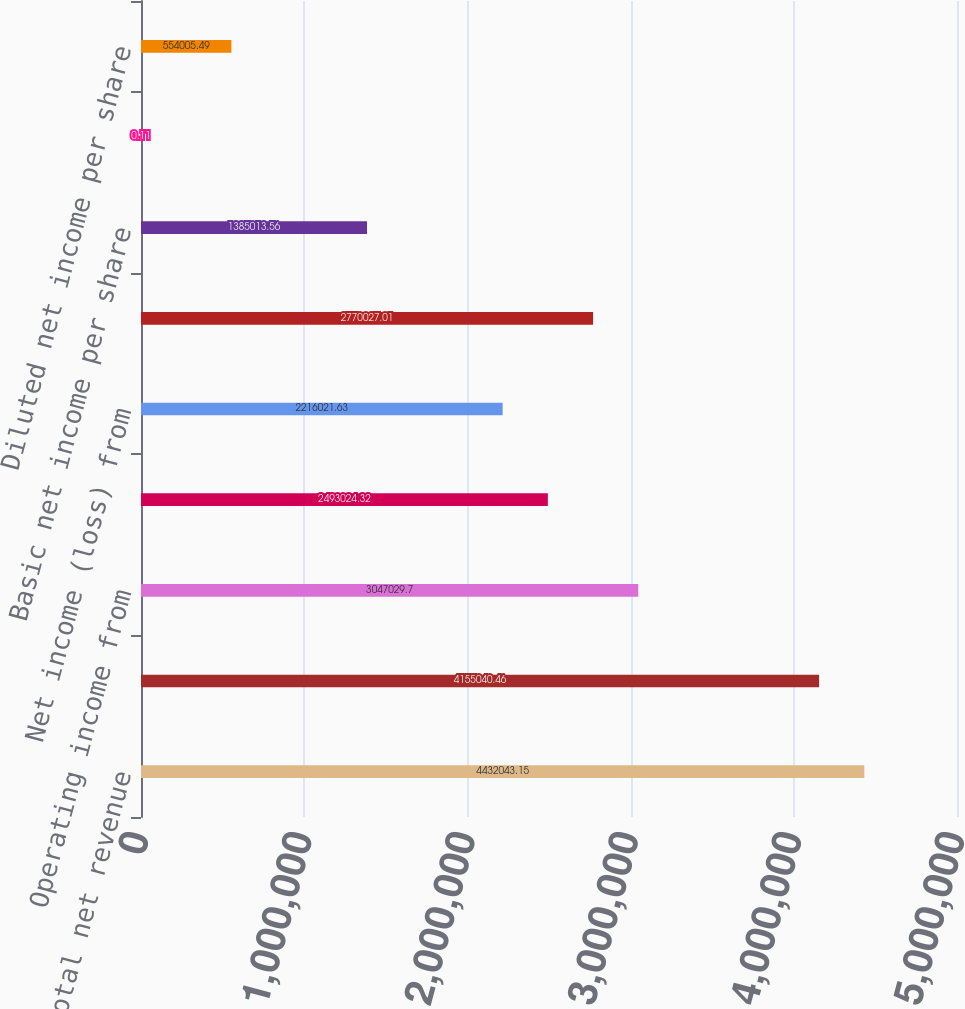Convert chart to OTSL. <chart><loc_0><loc_0><loc_500><loc_500><bar_chart><fcel>Total net revenue<fcel>Total costs and expenses<fcel>Operating income from<fcel>Net income from continuing<fcel>Net income (loss) from<fcel>Net income<fcel>Basic net income per share<fcel>Basic net income (loss) per<fcel>Diluted net income per share<nl><fcel>4.43204e+06<fcel>4.15504e+06<fcel>3.04703e+06<fcel>2.49302e+06<fcel>2.21602e+06<fcel>2.77003e+06<fcel>1.38501e+06<fcel>0.11<fcel>554005<nl></chart> 